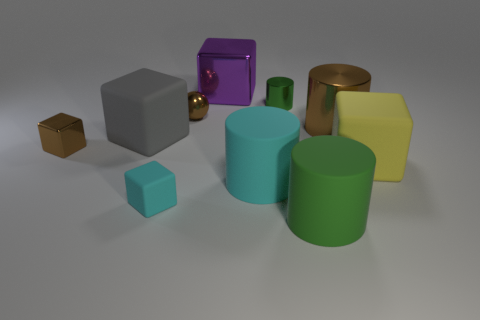Subtract 2 cubes. How many cubes are left? 3 Subtract all cyan blocks. How many blocks are left? 4 Subtract all large yellow cubes. How many cubes are left? 4 Subtract all gray cylinders. Subtract all brown blocks. How many cylinders are left? 4 Subtract all balls. How many objects are left? 9 Subtract 1 cyan cylinders. How many objects are left? 9 Subtract all cyan metal balls. Subtract all small brown shiny spheres. How many objects are left? 9 Add 7 yellow matte things. How many yellow matte things are left? 8 Add 9 purple metal spheres. How many purple metal spheres exist? 9 